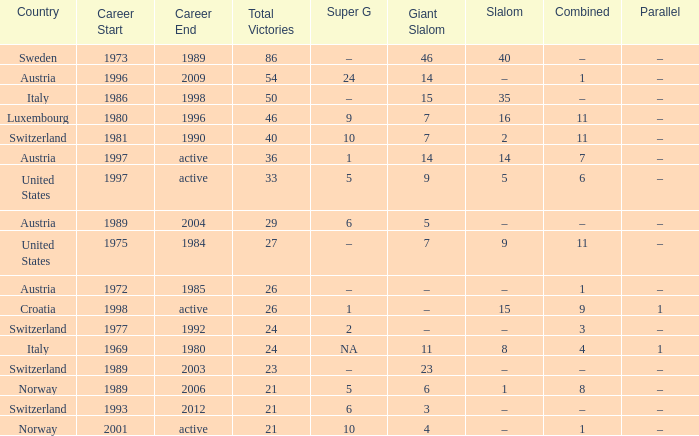What Career has a Parallel of –, a Combined of –, and a Giant Slalom of 5? 1989–2004. Would you mind parsing the complete table? {'header': ['Country', 'Career Start', 'Career End', 'Total Victories', 'Super G', 'Giant Slalom', 'Slalom', 'Combined', 'Parallel'], 'rows': [['Sweden', '1973', '1989', '86', '–', '46', '40', '–', '–'], ['Austria', '1996', '2009', '54', '24', '14', '–', '1', '–'], ['Italy', '1986', '1998', '50', '–', '15', '35', '–', '–'], ['Luxembourg', '1980', '1996', '46', '9', '7', '16', '11', '–'], ['Switzerland', '1981', '1990', '40', '10', '7', '2', '11', '–'], ['Austria', '1997', 'active', '36', '1', '14', '14', '7', '–'], ['United States', '1997', 'active', '33', '5', '9', '5', '6', '–'], ['Austria', '1989', '2004', '29', '6', '5', '–', '–', '–'], ['United States', '1975', '1984', '27', '–', '7', '9', '11', '–'], ['Austria', '1972', '1985', '26', '–', '–', '–', '1', '–'], ['Croatia', '1998', 'active', '26', '1', '–', '15', '9', '1'], ['Switzerland', '1977', '1992', '24', '2', '–', '–', '3', '–'], ['Italy', '1969', '1980', '24', 'NA', '11', '8', '4', '1'], ['Switzerland', '1989', '2003', '23', '–', '23', '–', '–', '–'], ['Norway', '1989', '2006', '21', '5', '6', '1', '8', '–'], ['Switzerland', '1993', '2012', '21', '6', '3', '–', '–', '–'], ['Norway', '2001', 'active', '21', '10', '4', '–', '1', '–']]} 